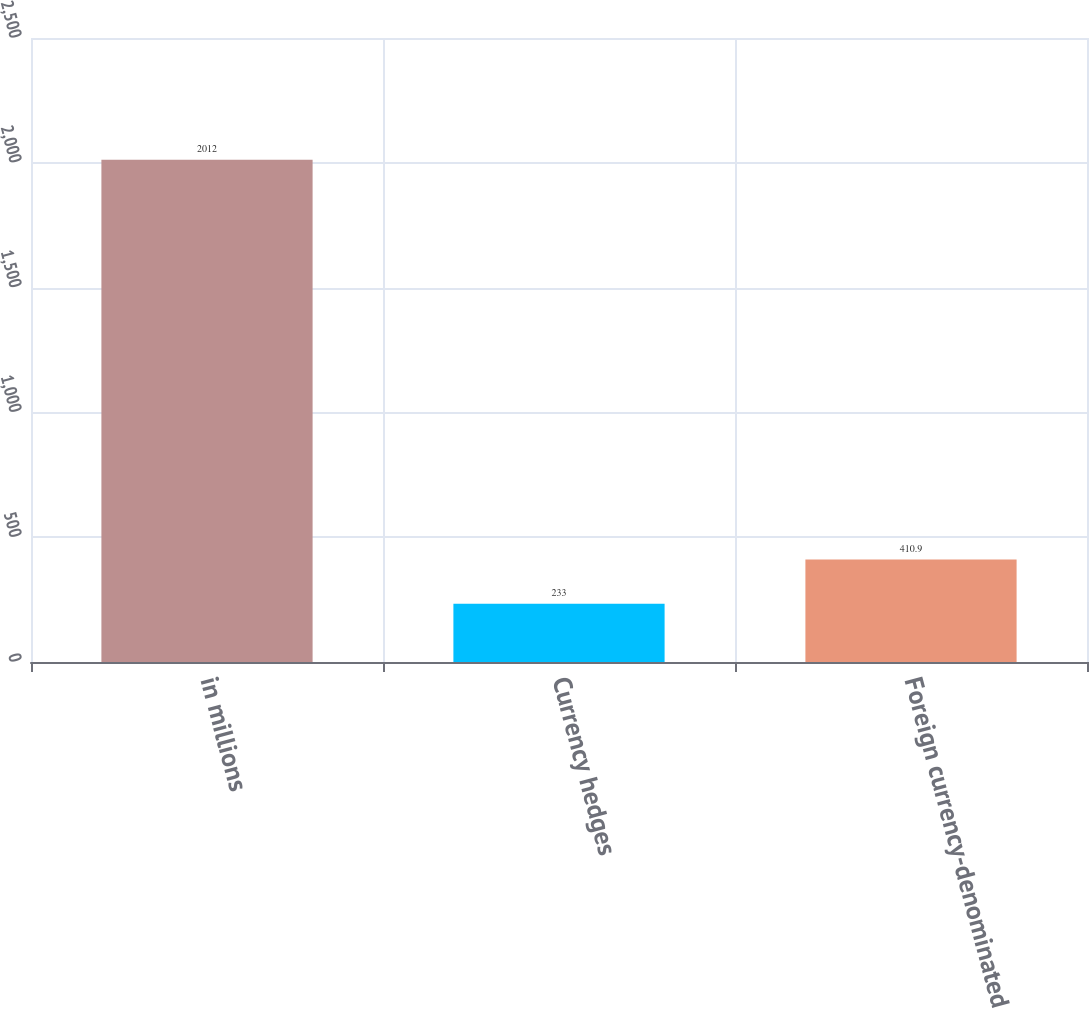<chart> <loc_0><loc_0><loc_500><loc_500><bar_chart><fcel>in millions<fcel>Currency hedges<fcel>Foreign currency-denominated<nl><fcel>2012<fcel>233<fcel>410.9<nl></chart> 